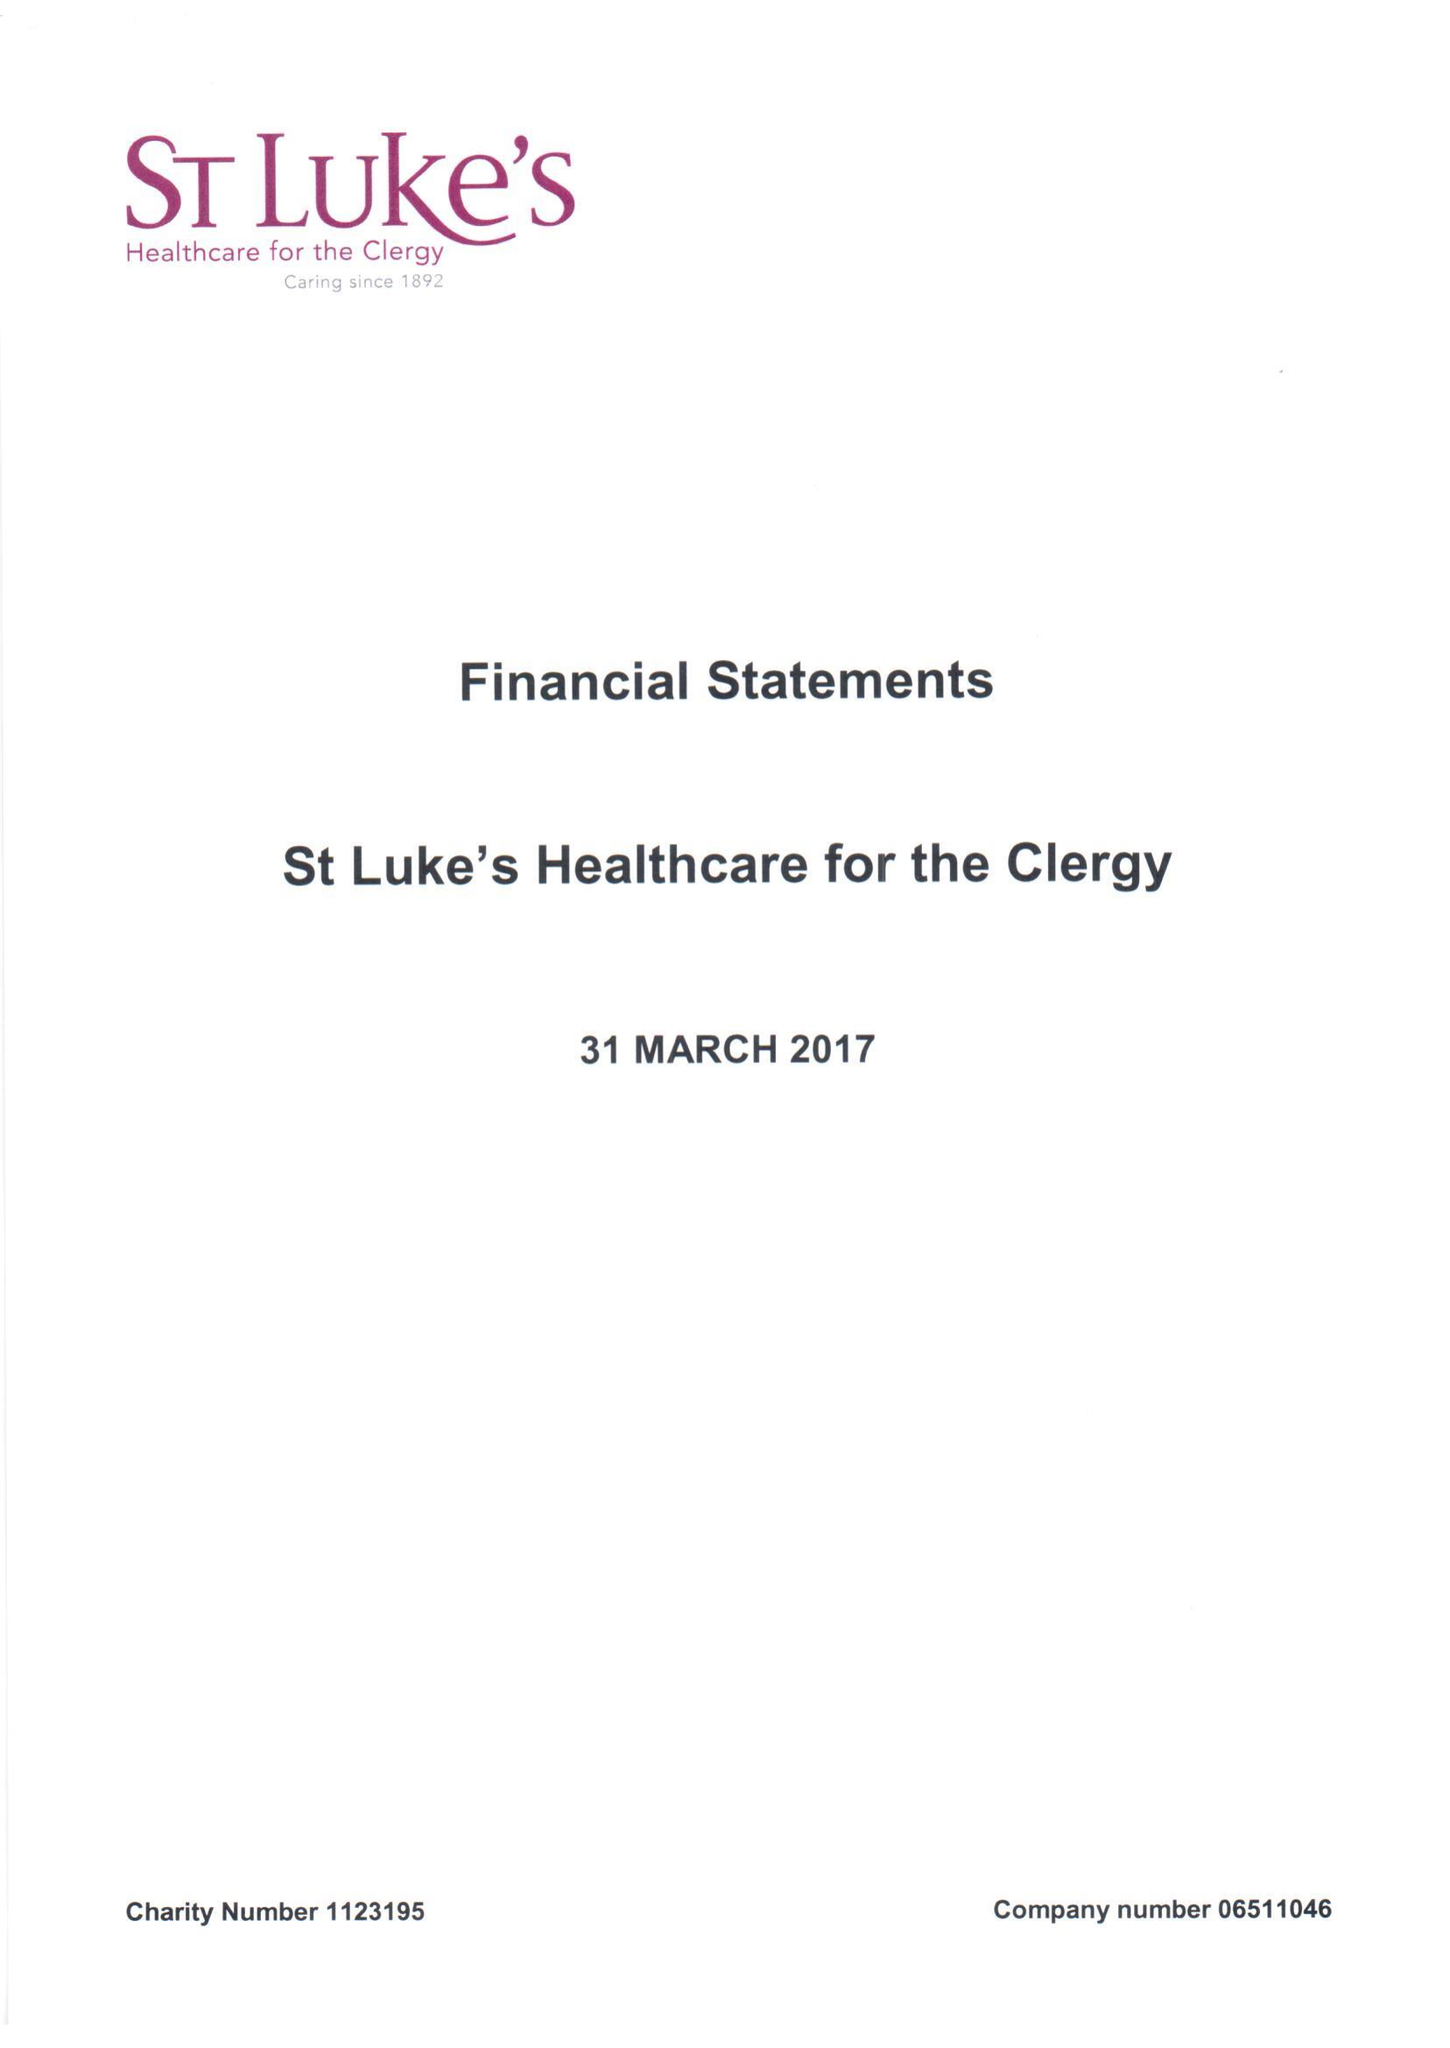What is the value for the charity_number?
Answer the question using a single word or phrase. 1123195 